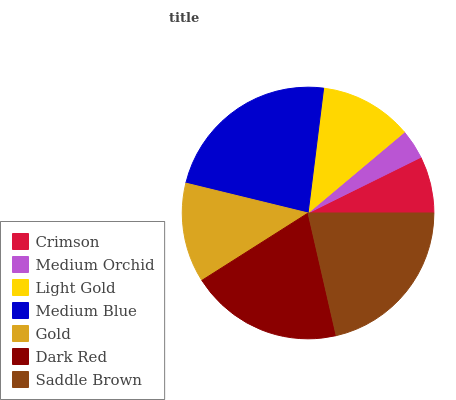Is Medium Orchid the minimum?
Answer yes or no. Yes. Is Medium Blue the maximum?
Answer yes or no. Yes. Is Light Gold the minimum?
Answer yes or no. No. Is Light Gold the maximum?
Answer yes or no. No. Is Light Gold greater than Medium Orchid?
Answer yes or no. Yes. Is Medium Orchid less than Light Gold?
Answer yes or no. Yes. Is Medium Orchid greater than Light Gold?
Answer yes or no. No. Is Light Gold less than Medium Orchid?
Answer yes or no. No. Is Gold the high median?
Answer yes or no. Yes. Is Gold the low median?
Answer yes or no. Yes. Is Medium Orchid the high median?
Answer yes or no. No. Is Medium Orchid the low median?
Answer yes or no. No. 